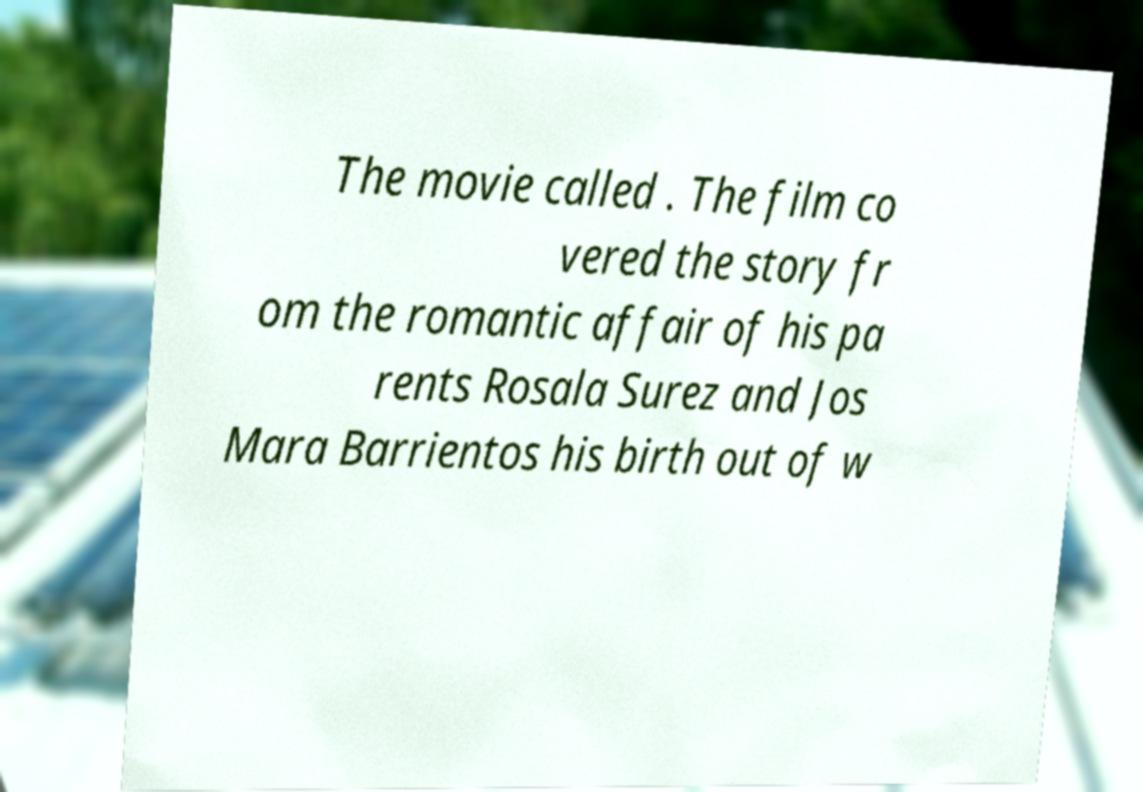Please identify and transcribe the text found in this image. The movie called . The film co vered the story fr om the romantic affair of his pa rents Rosala Surez and Jos Mara Barrientos his birth out of w 